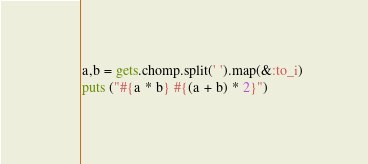<code> <loc_0><loc_0><loc_500><loc_500><_Ruby_>a,b = gets.chomp.split(' ').map(&:to_i)
puts ("#{a * b} #{(a + b) * 2}")
</code> 